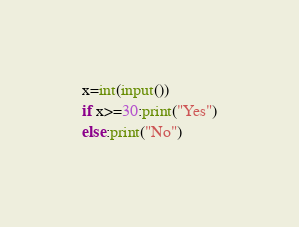<code> <loc_0><loc_0><loc_500><loc_500><_Python_>
x=int(input())
if x>=30:print("Yes")
else:print("No")</code> 